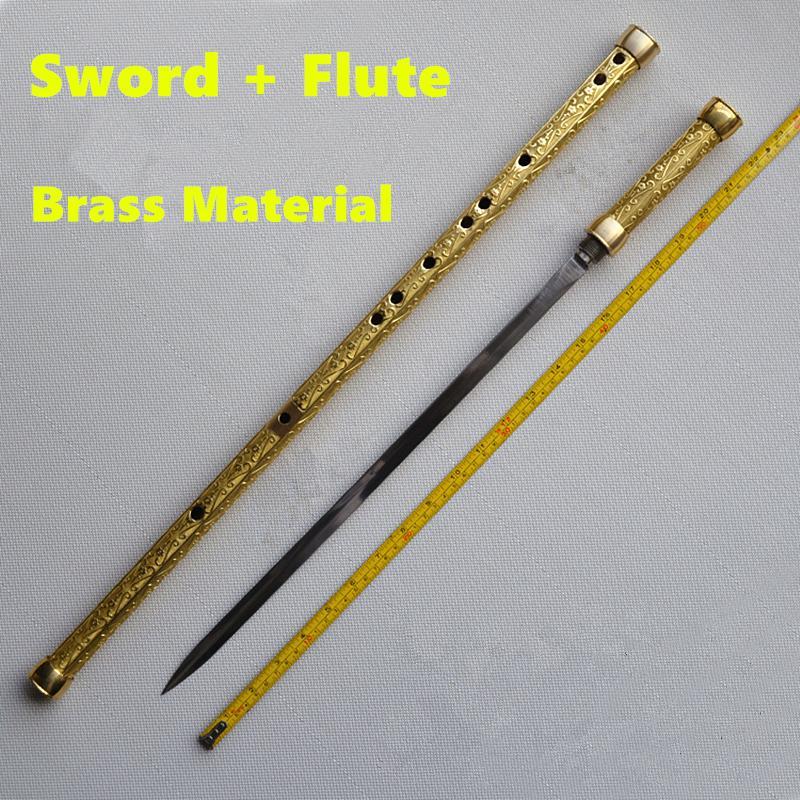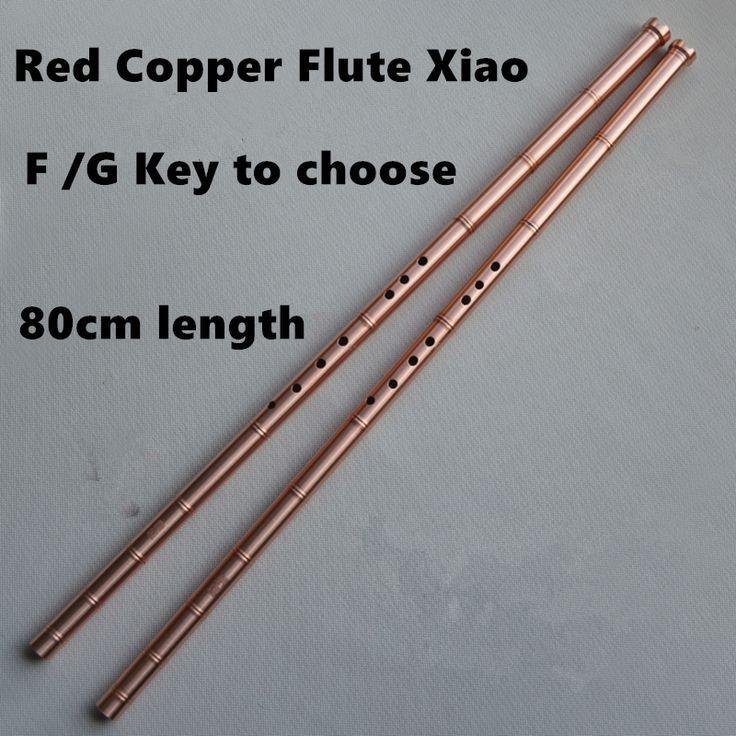The first image is the image on the left, the second image is the image on the right. Evaluate the accuracy of this statement regarding the images: "There are exactly five objects.". Is it true? Answer yes or no. Yes. 